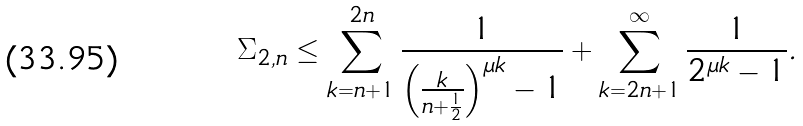Convert formula to latex. <formula><loc_0><loc_0><loc_500><loc_500>\Sigma _ { 2 , n } \leq \sum _ { k = n + 1 } ^ { 2 n } \frac { 1 } { \left ( \frac { k } { n + \frac { 1 } { 2 } } \right ) ^ { \mu k } - 1 } + \sum _ { k = 2 n + 1 } ^ { \infty } \frac { 1 } { 2 ^ { \mu k } - 1 } .</formula> 